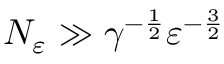Convert formula to latex. <formula><loc_0><loc_0><loc_500><loc_500>N _ { \varepsilon } \gg \gamma ^ { - \frac { 1 } { 2 } } \varepsilon ^ { - \frac { 3 } { 2 } }</formula> 